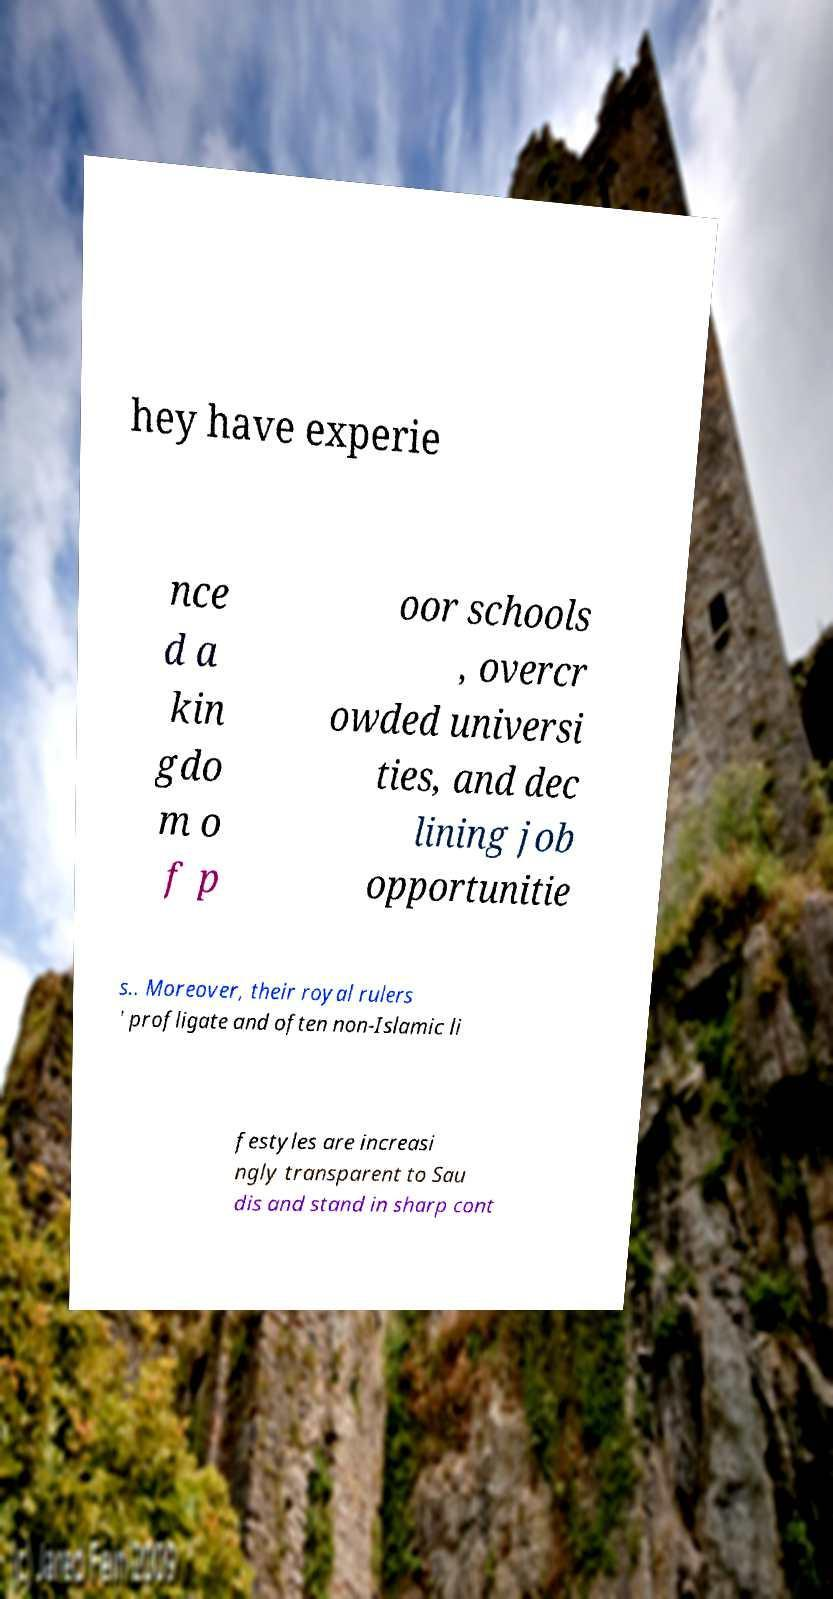There's text embedded in this image that I need extracted. Can you transcribe it verbatim? hey have experie nce d a kin gdo m o f p oor schools , overcr owded universi ties, and dec lining job opportunitie s.. Moreover, their royal rulers ' profligate and often non-Islamic li festyles are increasi ngly transparent to Sau dis and stand in sharp cont 